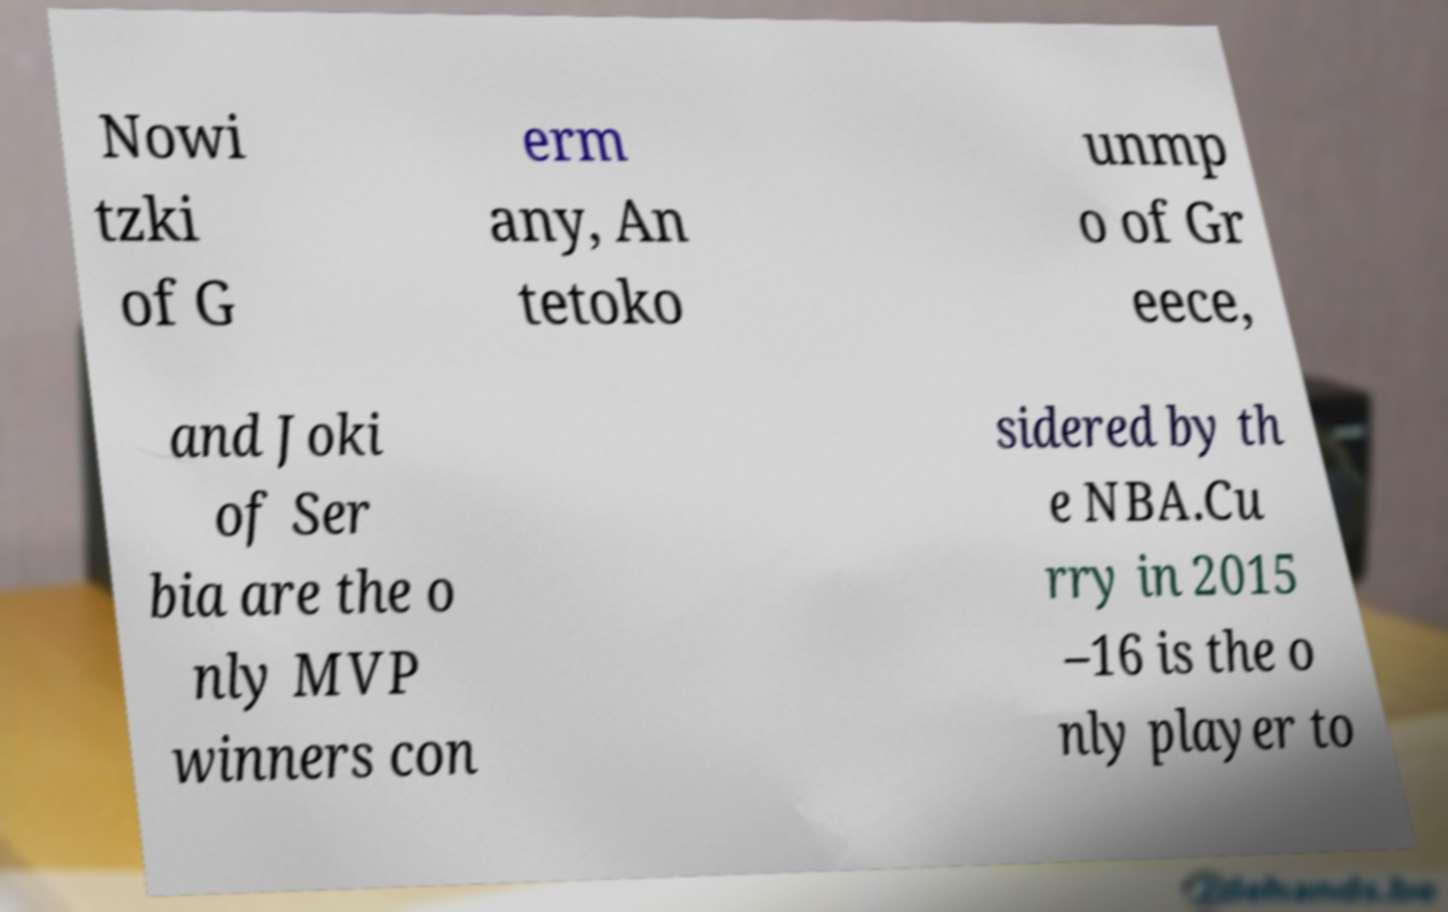For documentation purposes, I need the text within this image transcribed. Could you provide that? Nowi tzki of G erm any, An tetoko unmp o of Gr eece, and Joki of Ser bia are the o nly MVP winners con sidered by th e NBA.Cu rry in 2015 –16 is the o nly player to 